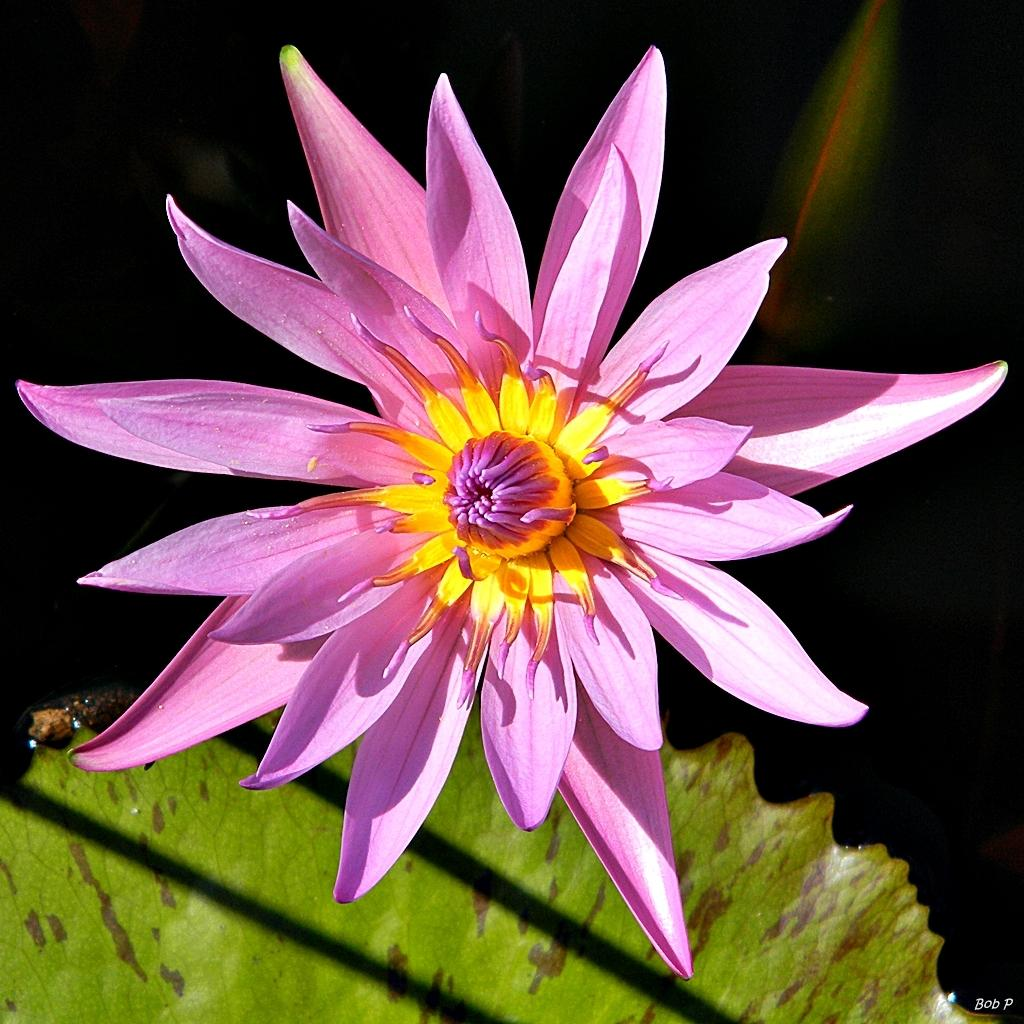What color is the flower in the image? The flower in the image is purple and yellow. What else can be seen at the bottom of the image? There are leaves visible at the bottom of the image. What type of silver material is used to create the garden in the image? There is no silver material or garden present in the image; it features a purple and yellow flower with leaves at the bottom. 